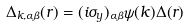Convert formula to latex. <formula><loc_0><loc_0><loc_500><loc_500>\Delta _ { { k } , \alpha \beta } ( { r } ) = ( i \sigma _ { y } ) _ { \alpha \beta } \psi ( { k } ) \Delta ( { r } )</formula> 